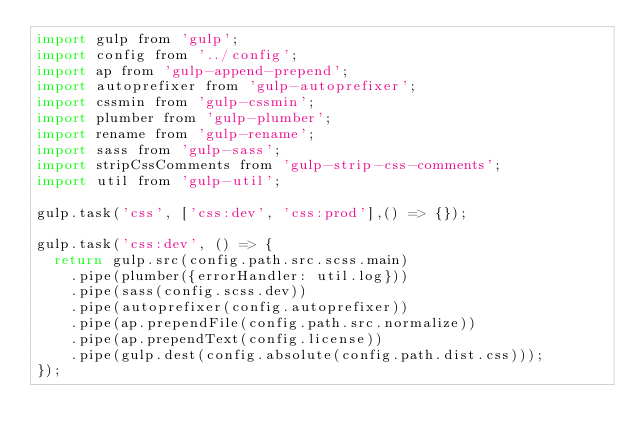<code> <loc_0><loc_0><loc_500><loc_500><_JavaScript_>import gulp from 'gulp';
import config from '../config';
import ap from 'gulp-append-prepend';
import autoprefixer from 'gulp-autoprefixer';
import cssmin from 'gulp-cssmin';
import plumber from 'gulp-plumber';
import rename from 'gulp-rename';
import sass from 'gulp-sass';
import stripCssComments from 'gulp-strip-css-comments';
import util from 'gulp-util';

gulp.task('css', ['css:dev', 'css:prod'],() => {});

gulp.task('css:dev', () => {
  return gulp.src(config.path.src.scss.main)
    .pipe(plumber({errorHandler: util.log}))
    .pipe(sass(config.scss.dev))
    .pipe(autoprefixer(config.autoprefixer))
    .pipe(ap.prependFile(config.path.src.normalize))
    .pipe(ap.prependText(config.license))
    .pipe(gulp.dest(config.absolute(config.path.dist.css)));
});
</code> 